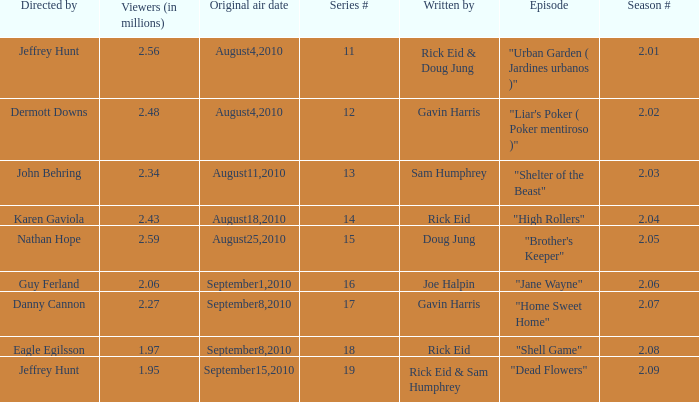What is the amount of viewers if the series number is 14? 2.43. 